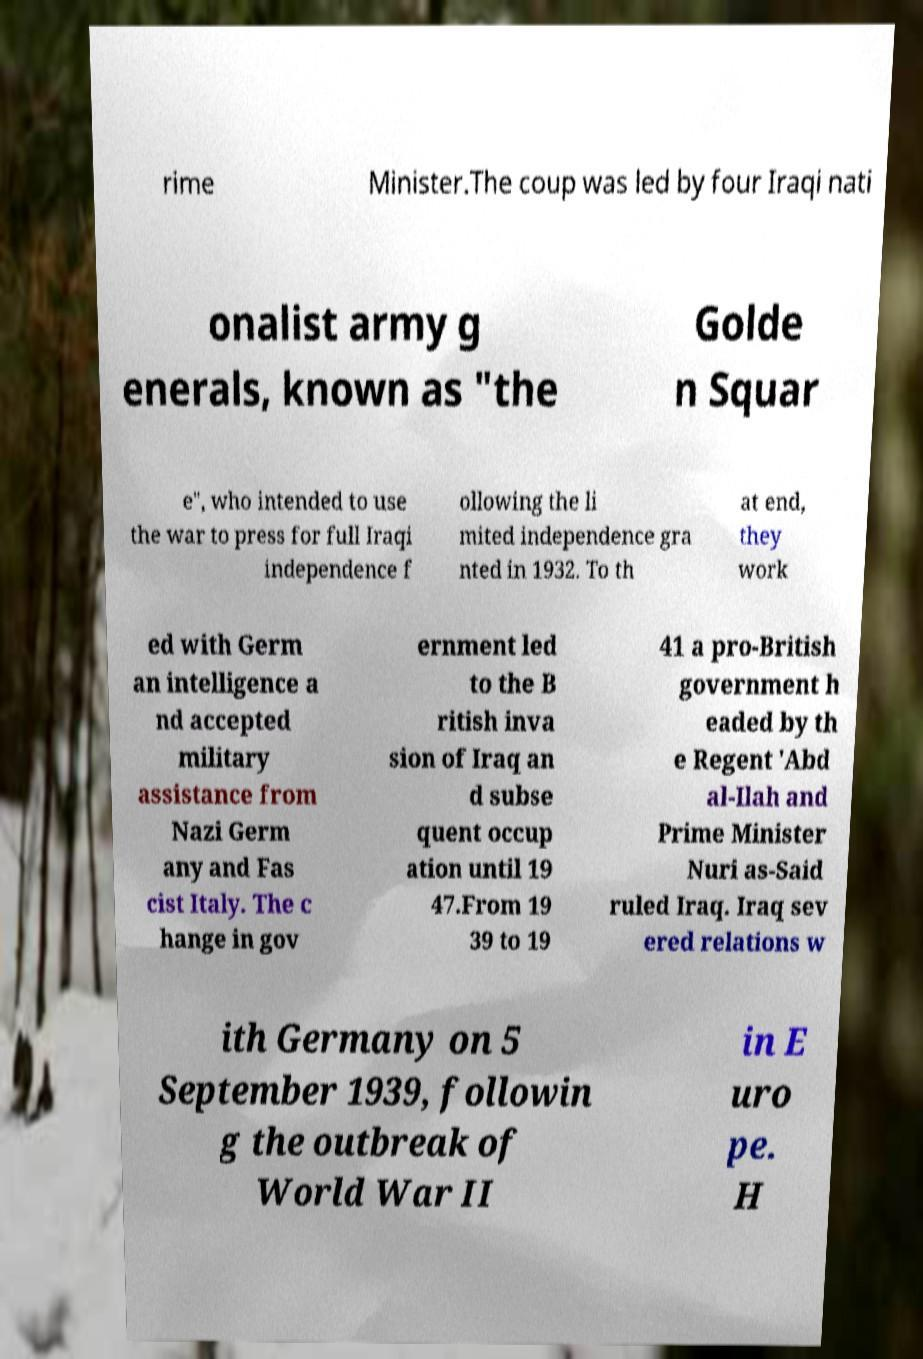Please read and relay the text visible in this image. What does it say? rime Minister.The coup was led by four Iraqi nati onalist army g enerals, known as "the Golde n Squar e", who intended to use the war to press for full Iraqi independence f ollowing the li mited independence gra nted in 1932. To th at end, they work ed with Germ an intelligence a nd accepted military assistance from Nazi Germ any and Fas cist Italy. The c hange in gov ernment led to the B ritish inva sion of Iraq an d subse quent occup ation until 19 47.From 19 39 to 19 41 a pro-British government h eaded by th e Regent 'Abd al-Ilah and Prime Minister Nuri as-Said ruled Iraq. Iraq sev ered relations w ith Germany on 5 September 1939, followin g the outbreak of World War II in E uro pe. H 